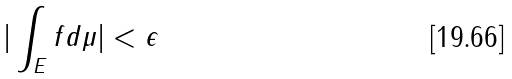Convert formula to latex. <formula><loc_0><loc_0><loc_500><loc_500>| \int _ { E } f d \mu | < \epsilon</formula> 